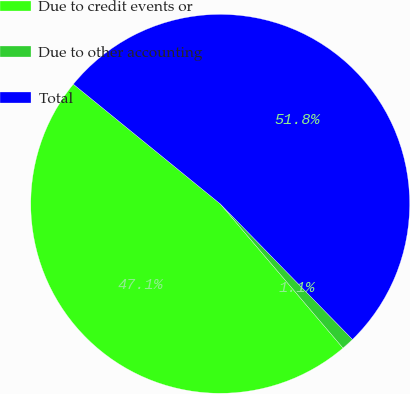Convert chart. <chart><loc_0><loc_0><loc_500><loc_500><pie_chart><fcel>Due to credit events or<fcel>Due to other accounting<fcel>Total<nl><fcel>47.1%<fcel>1.08%<fcel>51.81%<nl></chart> 